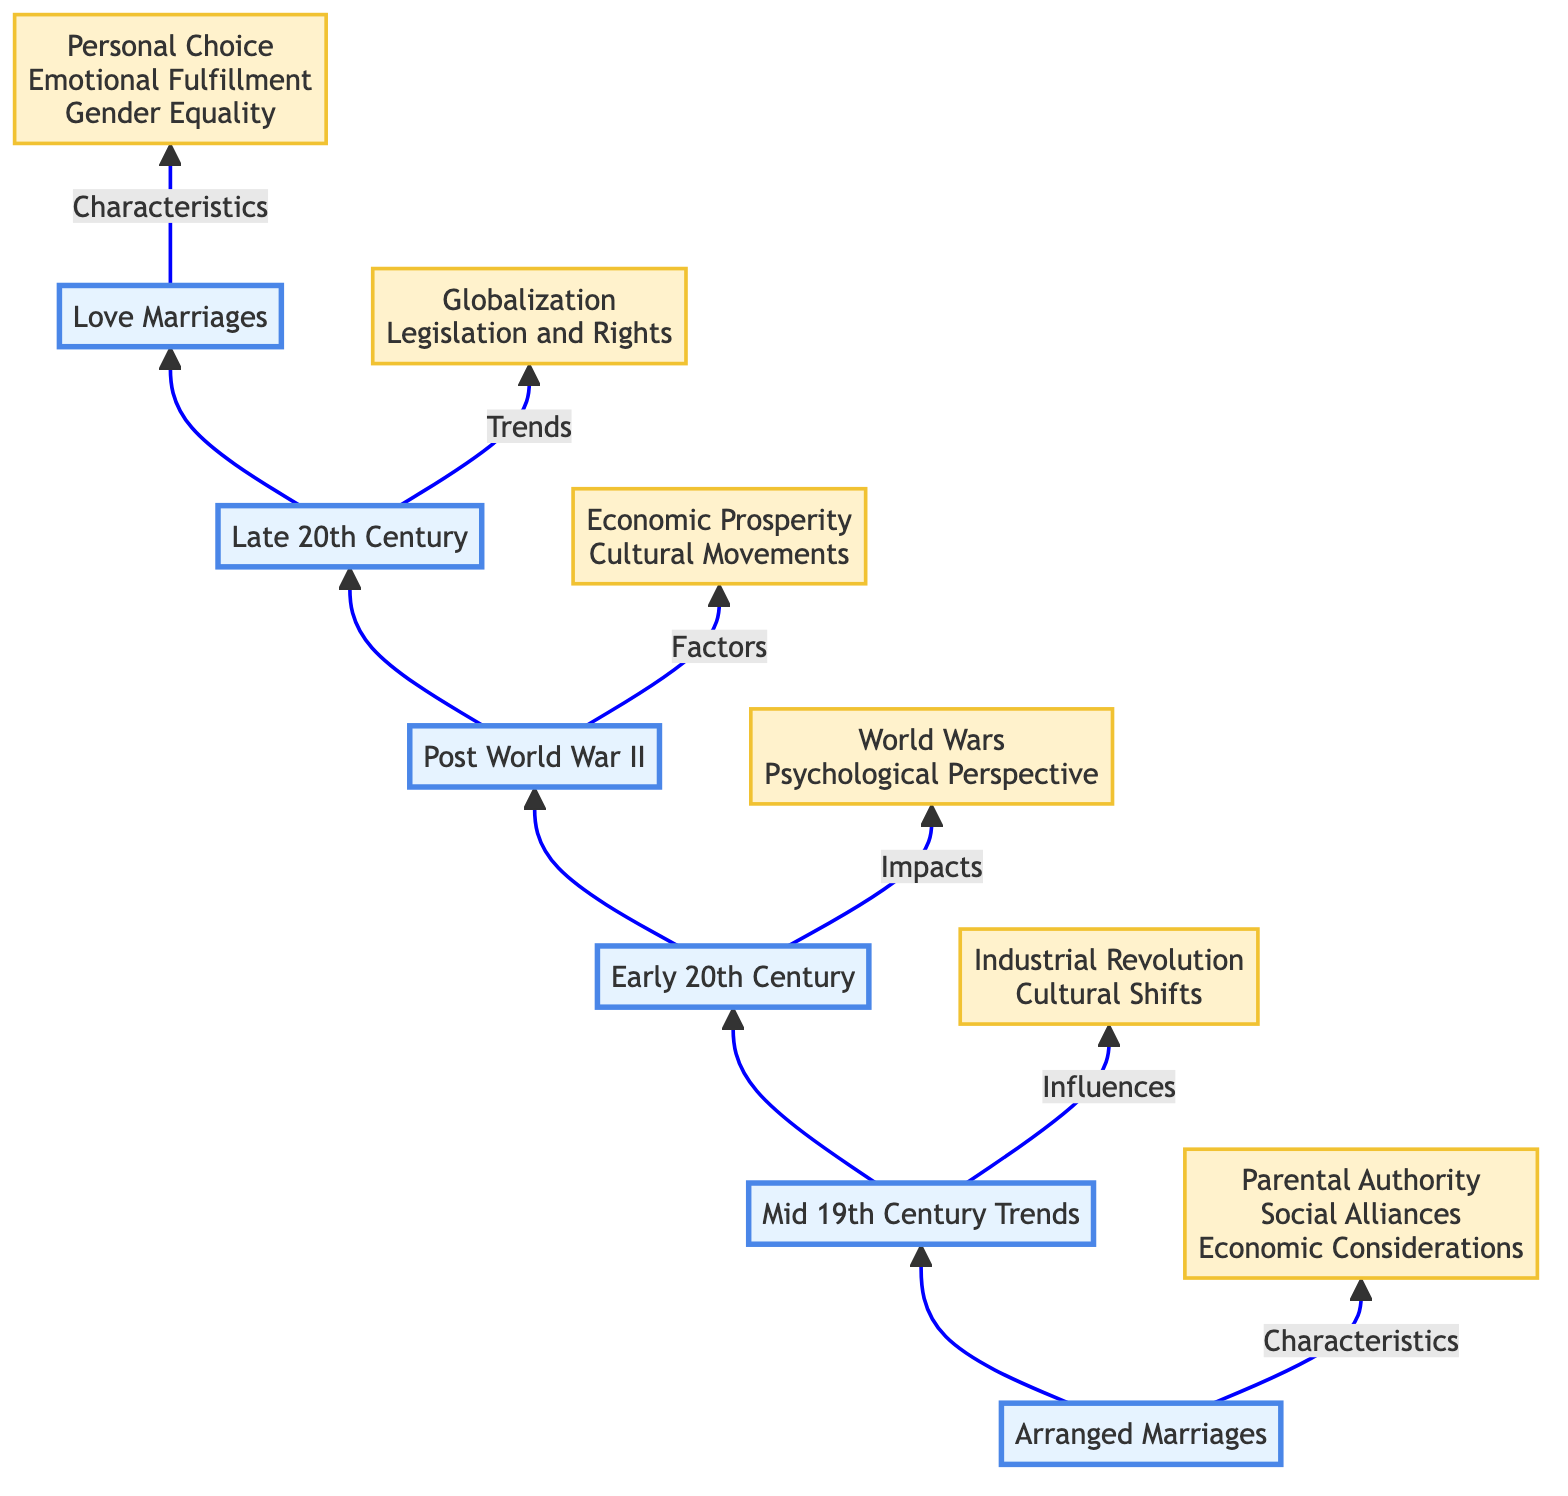What are the characteristics of Arranged Marriages? The diagram shows that the characteristics of Arranged Marriages are "Parental Authority, Social Alliances, Economic Considerations." These are indicated as a specific set of features linked to the Arranged Marriages node.
Answer: Parental Authority, Social Alliances, Economic Considerations Which historical examples are provided for Arranged Marriages? The diagram lists "Royal Dynasties in Europe, Caste-based Marriages in India, Clan Alliances in East Asia" as historical examples linked to the Arranged Marriages node. These historical references illustrate the practice in different contexts.
Answer: Royal Dynasties in Europe, Caste-based Marriages in India, Clan Alliances in East Asia What trends influenced the Mid 19th Century? The arrow from Mid 19th Century Trends points to influences that include "Industrial Revolution, Cultural Shifts." This means these factors are critical in understanding the changes during this period.
Answer: Industrial Revolution, Cultural Shifts How did World Wars impact marriage norms in the Early 20th Century? From the Early 20th Century node, the impacts listed are "Disrupted Traditional Norms, Increased Women's Participation in Workforce, Shift in Gender Roles." This indicates how the wars brought about significant changes in marriage dynamics.
Answer: Disrupted Traditional Norms, Increased Women's Participation in Workforce, Shift in Gender Roles What factors characterized the Post World War II era? The diagram specifies that factors in the Post World War II section include "Economic Prosperity, Cultural Movements." The arrow shows these two aspects helped shape societal views on marriage after the war.
Answer: Economic Prosperity, Cultural Movements How did Globalization affect marriage norms in the Late 20th Century? The Late 20th Century node details "Cross-Cultural Marriages, Influence of Media, Rise of Global Communications" as trends, indicating that globalization broadened the scope of marriage norms during that time.
Answer: Cross-Cultural Marriages, Influence of Media, Rise of Global Communications What are the characteristics of Love Marriages? According to the diagram, Love Marriages are characterized by "Personal Choice, Emotional Fulfillment, Gender Equality," defining what distinguishes them from earlier marriage forms.
Answer: Personal Choice, Emotional Fulfillment, Gender Equality What is the relationship between Arranged Marriages and Love Marriages in the flow chart? The chart shows a clear progression from Arranged Marriages at the bottom to Love Marriages at the top. This indicates a transformation in societal norms from one marriage type to another as represented in the upward flow.
Answer: Transformation from Arranged to Love Marriages Which node follows Post World War II in the diagram? In the upward flow of the diagram, Post World War II points to the Late 20th Century. This indicates that events and changes in marriage norms of the late 20th century were influenced by the preceding post-war context.
Answer: Late 20th Century 